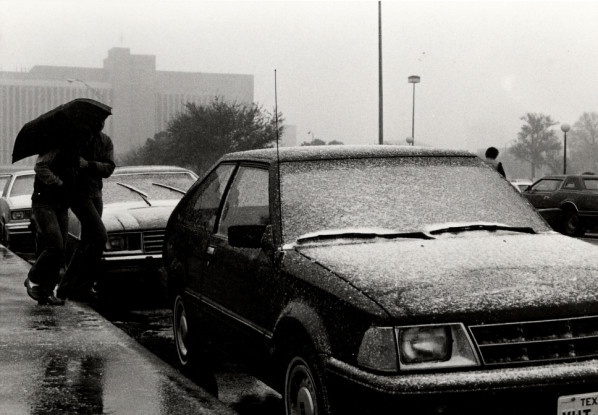Describe the objects in this image and their specific colors. I can see car in white, black, darkgray, gray, and lightgray tones, people in white, black, gray, and darkgray tones, car in white, black, darkgray, gray, and lightgray tones, car in white, black, and gray tones, and umbrella in white, black, and gray tones in this image. 